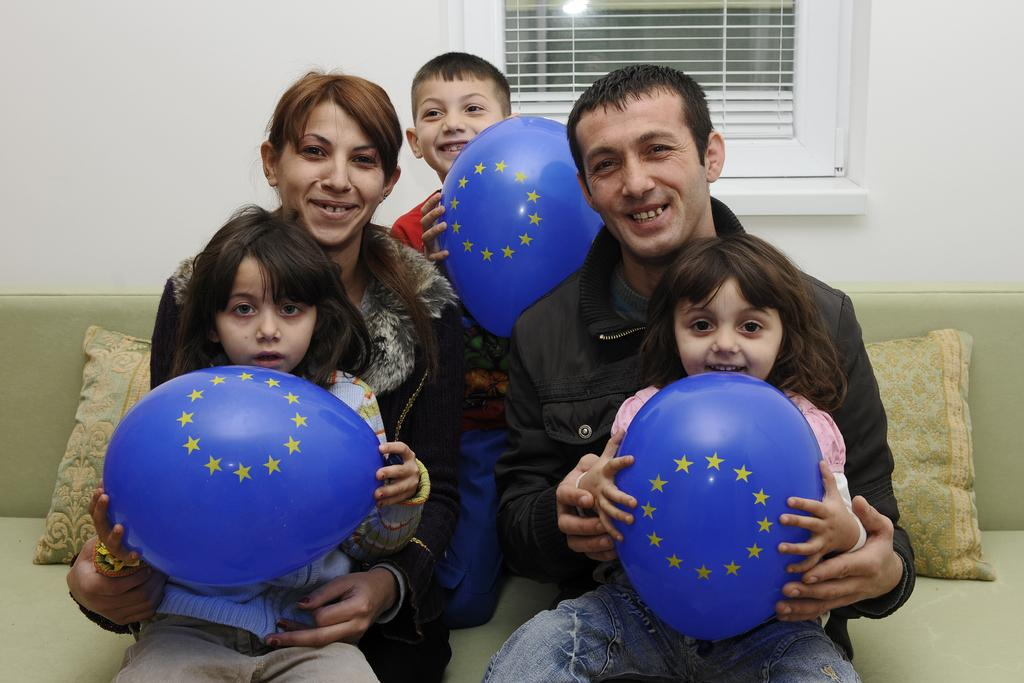How many people are in the image? There are two persons in the image. What are the persons doing in the image? The persons are sitting on a sofa. What are the kids holding in the image? The kids are holding balloons. Where is the window located in the image? There is a window at the top of the image. What type of wound can be seen on the person's arm in the image? There is no wound visible on any person's arm in the image. What substance is being used to fill the balloons in the image? The image does not show the process of filling the balloons, so it is not possible to determine the substance being used. 